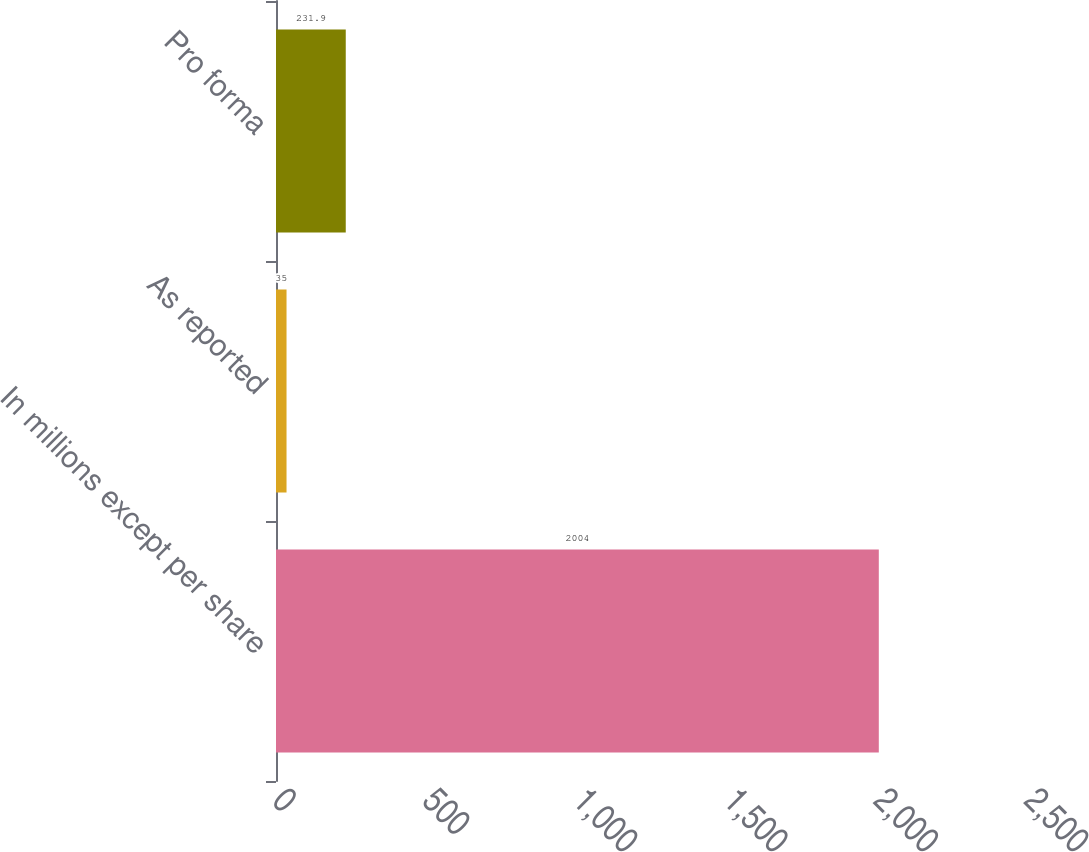Convert chart to OTSL. <chart><loc_0><loc_0><loc_500><loc_500><bar_chart><fcel>In millions except per share<fcel>As reported<fcel>Pro forma<nl><fcel>2004<fcel>35<fcel>231.9<nl></chart> 